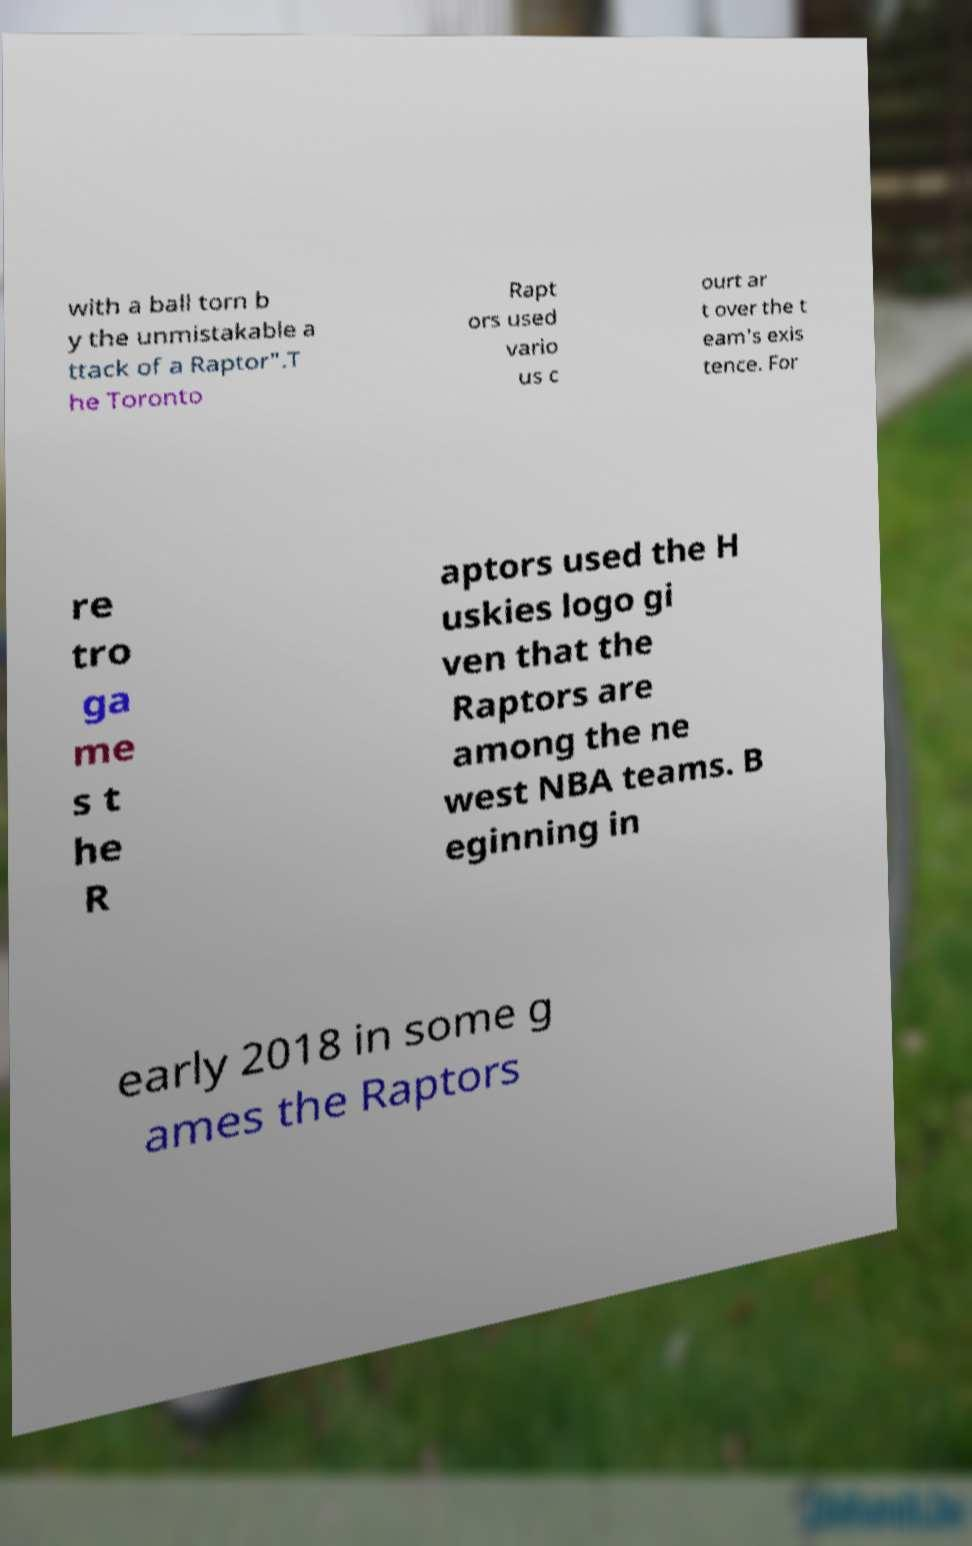Could you assist in decoding the text presented in this image and type it out clearly? with a ball torn b y the unmistakable a ttack of a Raptor".T he Toronto Rapt ors used vario us c ourt ar t over the t eam's exis tence. For re tro ga me s t he R aptors used the H uskies logo gi ven that the Raptors are among the ne west NBA teams. B eginning in early 2018 in some g ames the Raptors 